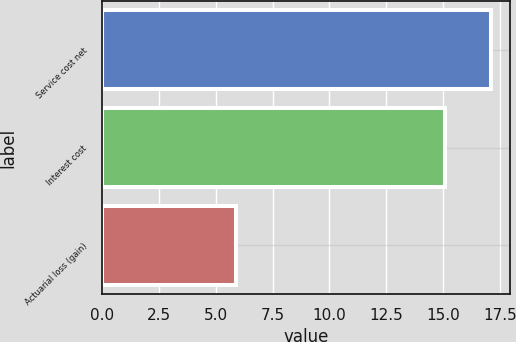Convert chart to OTSL. <chart><loc_0><loc_0><loc_500><loc_500><bar_chart><fcel>Service cost net<fcel>Interest cost<fcel>Actuarial loss (gain)<nl><fcel>17.1<fcel>15.1<fcel>5.9<nl></chart> 